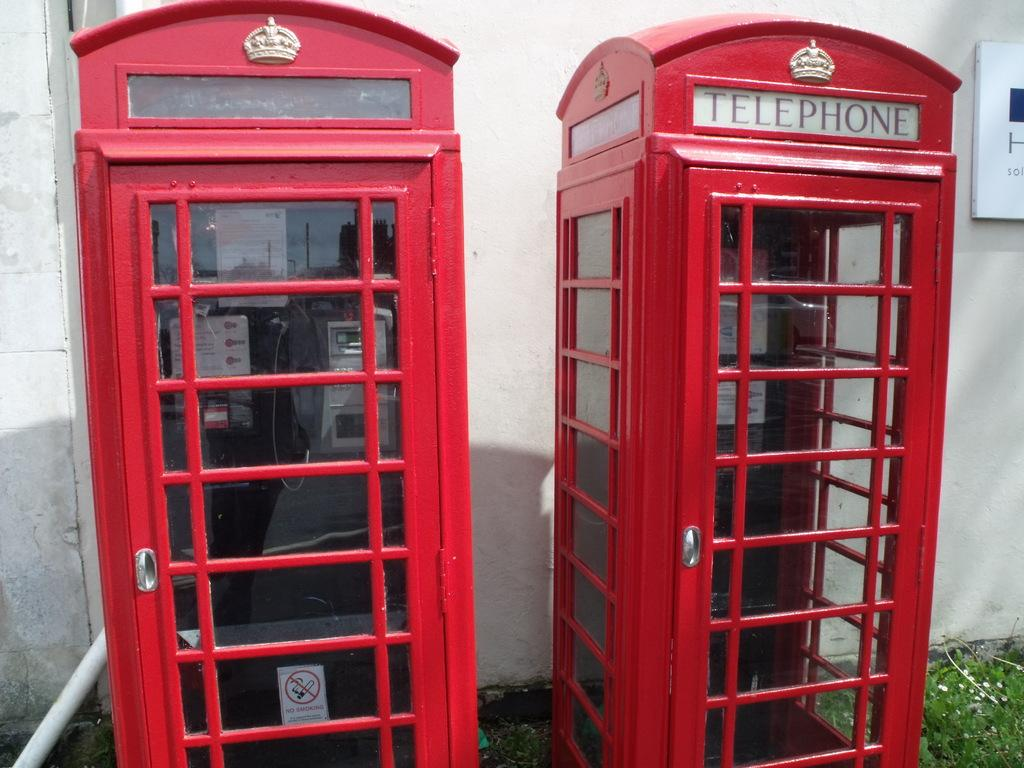How many telephone booths are in the image? There are two telephone booths in the image. What can be seen in the background of the image? There is a wall in the background of the image. What nation is promoting peace in the image? There is no reference to a nation or peace promotion in the image; it only features two telephone booths and a wall in the background. 